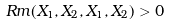Convert formula to latex. <formula><loc_0><loc_0><loc_500><loc_500>R m ( X _ { 1 } , X _ { 2 } , X _ { 1 } , X _ { 2 } ) > 0</formula> 